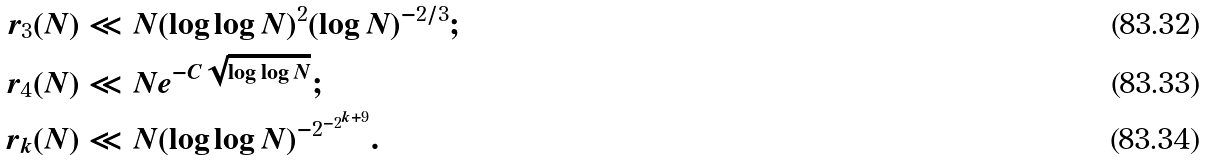Convert formula to latex. <formula><loc_0><loc_0><loc_500><loc_500>r _ { 3 } ( N ) & \ll N ( \log \log N ) ^ { 2 } ( \log N ) ^ { - 2 / 3 } ; \\ r _ { 4 } ( N ) & \ll N e ^ { - C \sqrt { \log \log N } } ; \\ r _ { k } ( N ) & \ll N ( \log \log N ) ^ { - 2 ^ { - 2 ^ { k + 9 } } } .</formula> 